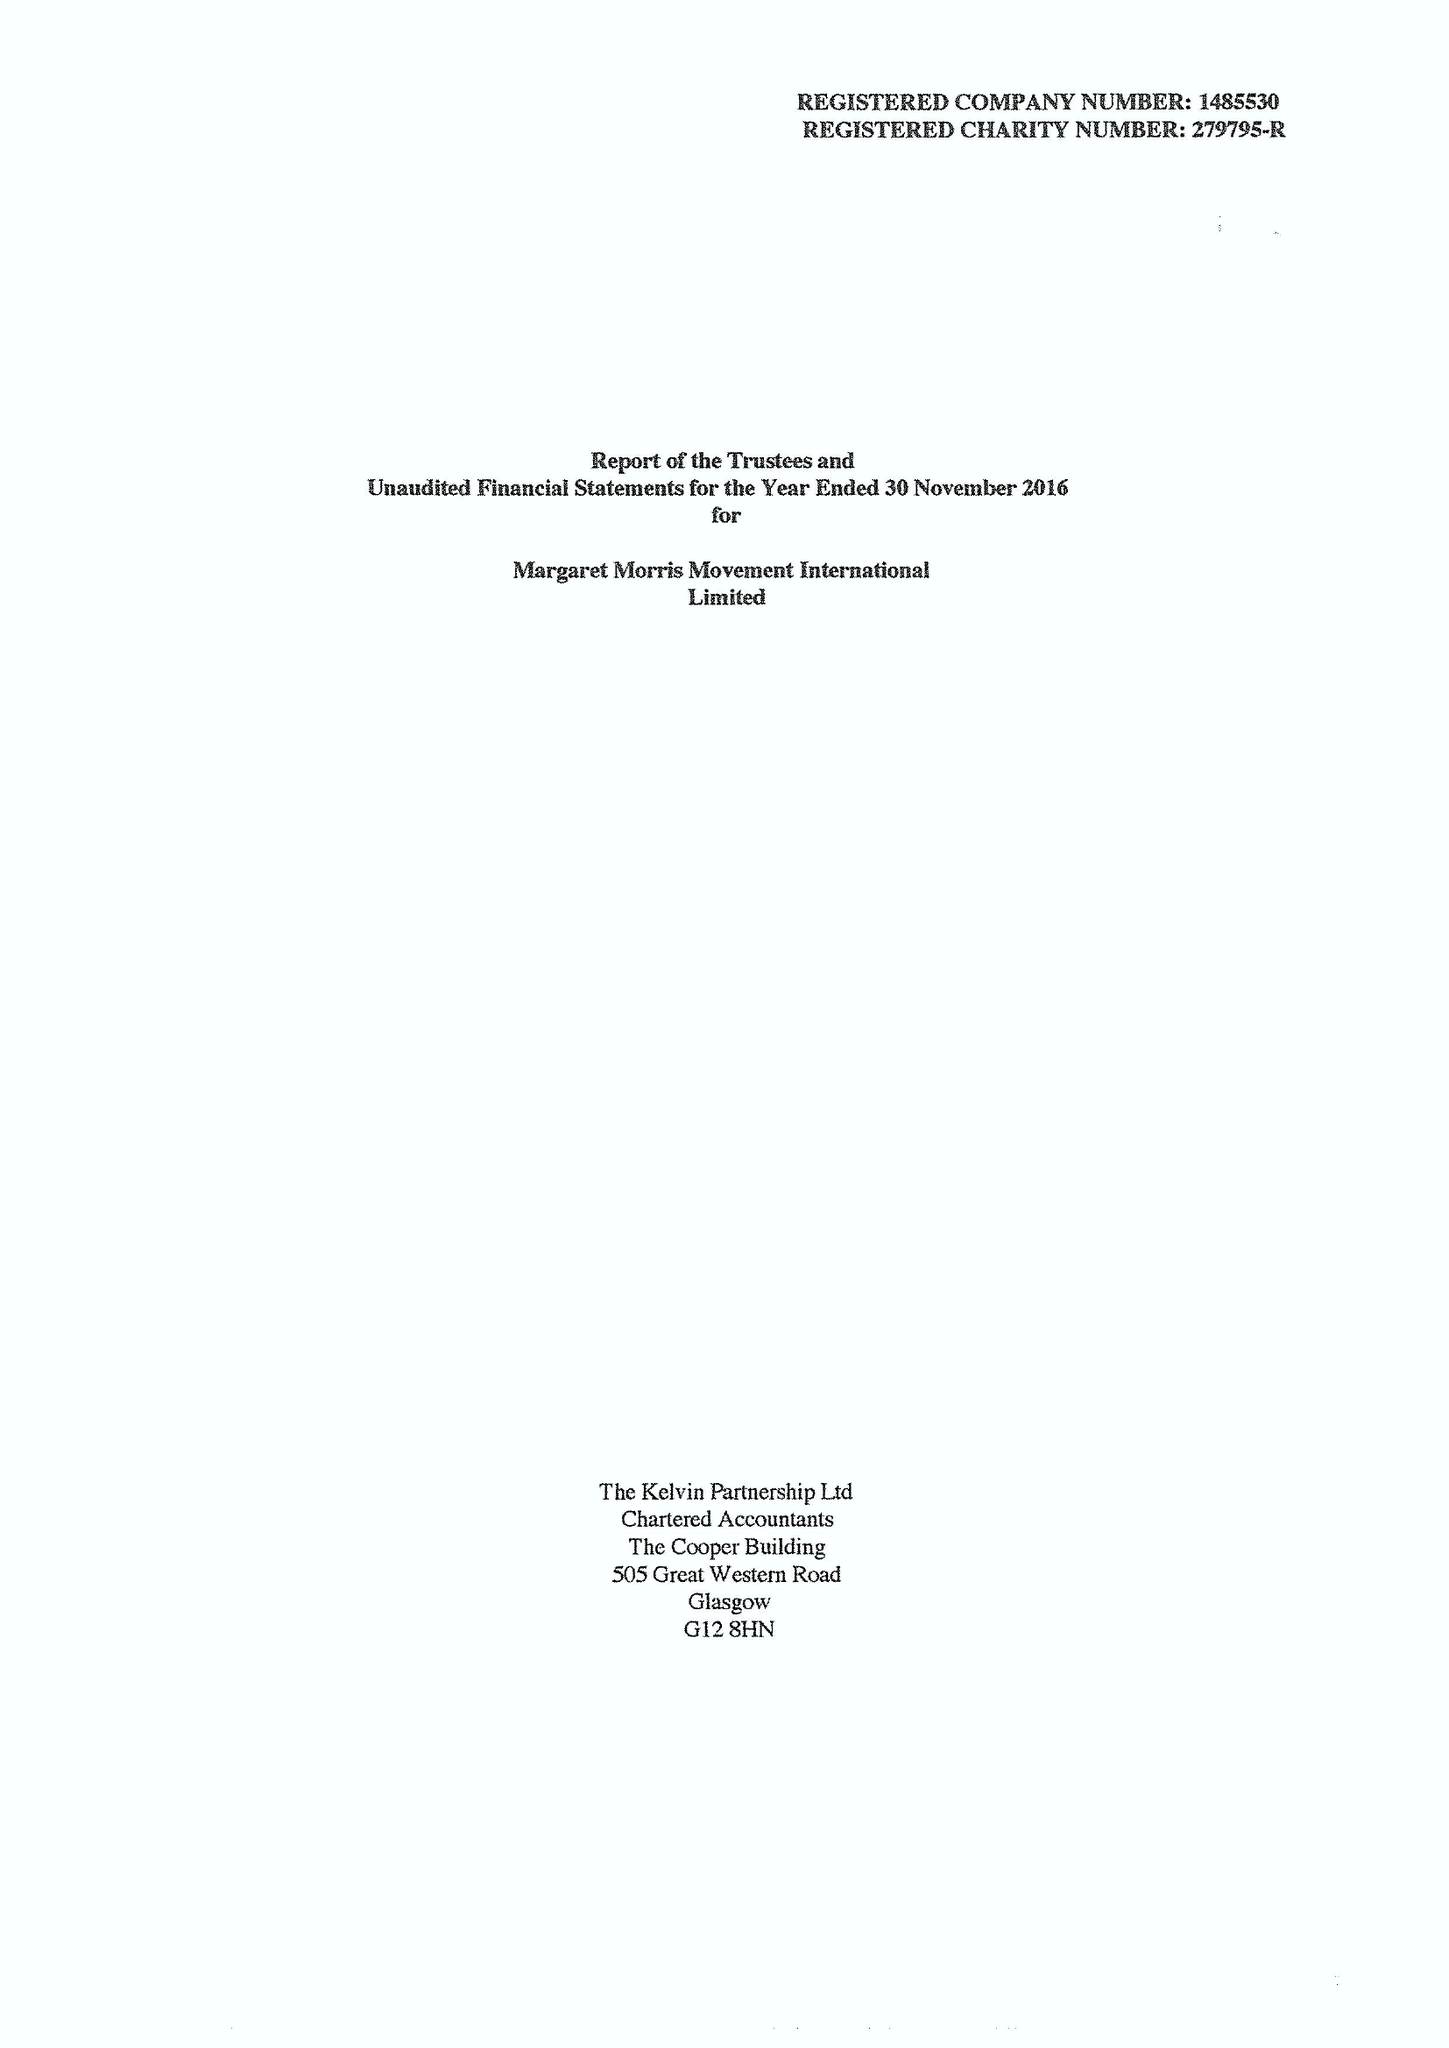What is the value for the charity_name?
Answer the question using a single word or phrase. Margaret Morris Movement International Ltd. 